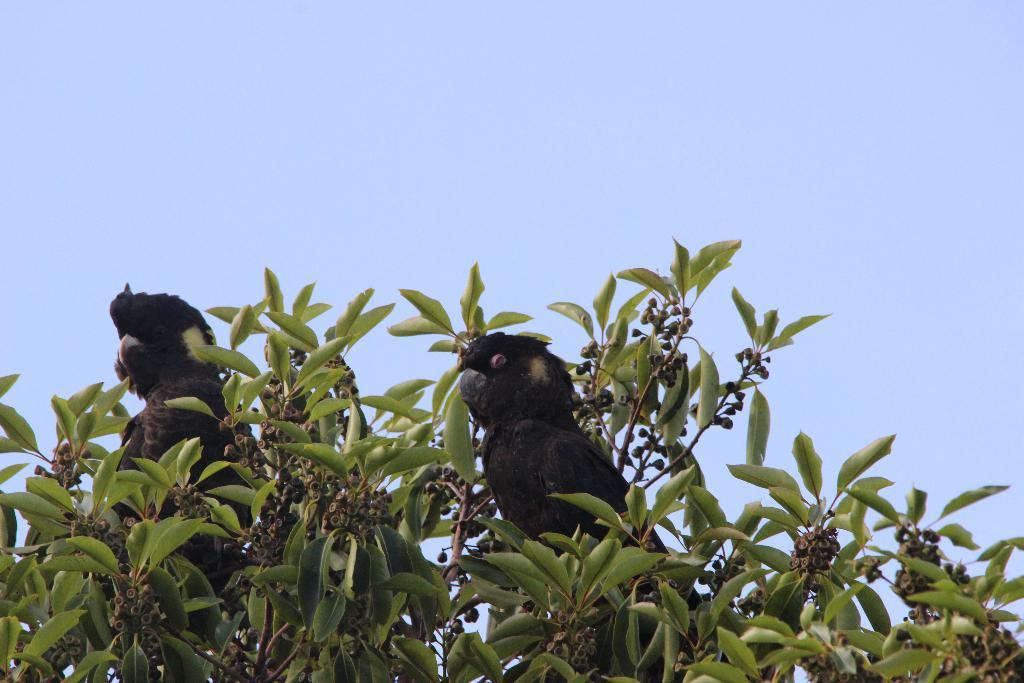How many birds are present in the image? There are two birds in the image. What colors are the birds? The birds are black and white in color. Where are the birds located in the image? The birds are on a tree. What colors are the tree's leaves? The tree is green and brown in color. What can be seen in the background of the image? The sky is visible in the background of the image. How does the disgust factor of the birds compare to that of a cucumber in the image? There is no mention of a cucumber or any concept of disgust in the image, so it is not possible to make a comparison. 